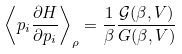<formula> <loc_0><loc_0><loc_500><loc_500>\left \langle p _ { i } \frac { \partial H } { \partial p _ { i } } \right \rangle _ { \rho } = \frac { 1 } { \beta } \frac { \mathcal { G } ( \beta , V ) } { G ( \beta , V ) }</formula> 